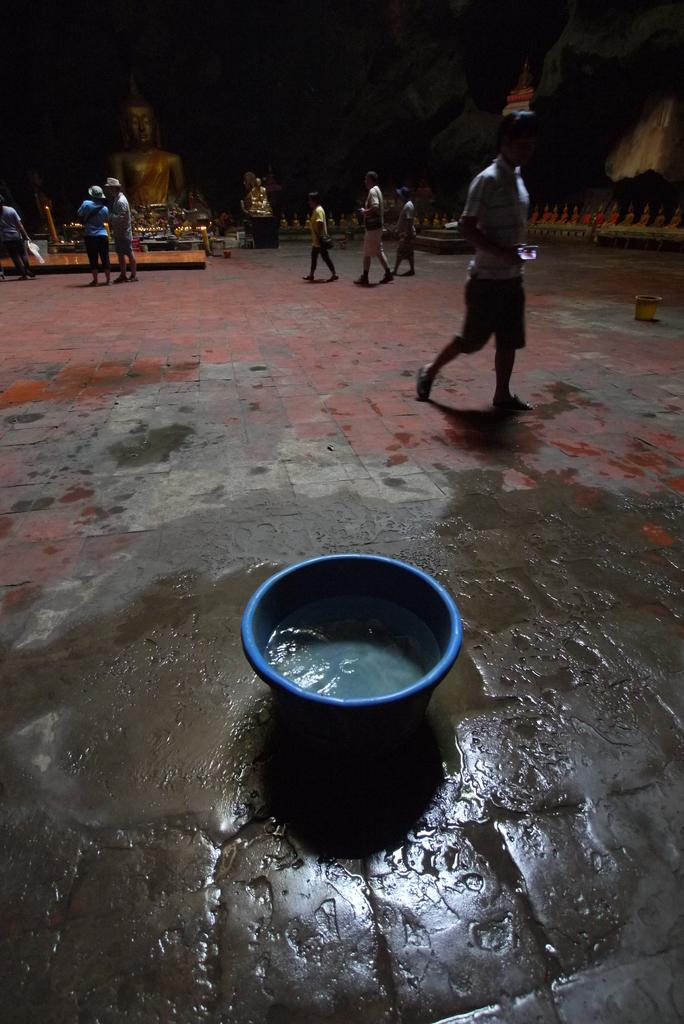What is in the tub that is visible in the image? There is water in the tub. What can be seen behind the tub in the image? There are people walking behind the tub. What is the location of the people in relation to the statue? The people are in front of a statue. How would you describe the lighting in the image? The background of the image is dark. What flavor of ice cream are the people holding in the image? There is no ice cream present in the image; it features people walking behind a tub with water. 